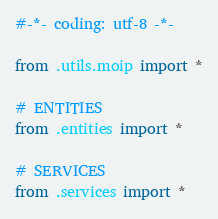Convert code to text. <code><loc_0><loc_0><loc_500><loc_500><_Python_>#-*- coding: utf-8 -*-

from .utils.moip import *

# ENTITIES
from .entities import *

# SERVICES
from .services import *
</code> 